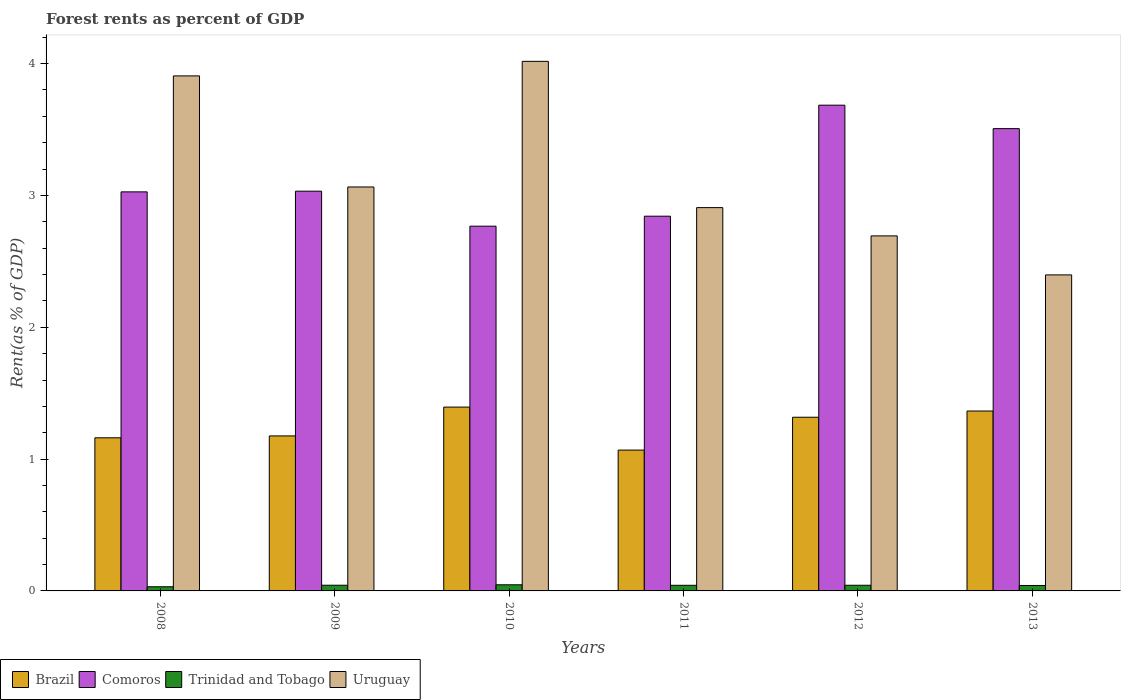How many different coloured bars are there?
Your answer should be very brief. 4. In how many cases, is the number of bars for a given year not equal to the number of legend labels?
Your answer should be very brief. 0. What is the forest rent in Trinidad and Tobago in 2012?
Your response must be concise. 0.04. Across all years, what is the maximum forest rent in Uruguay?
Provide a short and direct response. 4.02. Across all years, what is the minimum forest rent in Uruguay?
Your answer should be very brief. 2.4. In which year was the forest rent in Comoros maximum?
Your answer should be very brief. 2012. What is the total forest rent in Comoros in the graph?
Your response must be concise. 18.86. What is the difference between the forest rent in Brazil in 2011 and that in 2012?
Your response must be concise. -0.25. What is the difference between the forest rent in Comoros in 2011 and the forest rent in Uruguay in 2013?
Your answer should be compact. 0.45. What is the average forest rent in Brazil per year?
Keep it short and to the point. 1.25. In the year 2011, what is the difference between the forest rent in Brazil and forest rent in Comoros?
Your response must be concise. -1.77. In how many years, is the forest rent in Trinidad and Tobago greater than 1 %?
Give a very brief answer. 0. What is the ratio of the forest rent in Trinidad and Tobago in 2008 to that in 2013?
Provide a succinct answer. 0.76. Is the forest rent in Comoros in 2008 less than that in 2010?
Keep it short and to the point. No. Is the difference between the forest rent in Brazil in 2008 and 2010 greater than the difference between the forest rent in Comoros in 2008 and 2010?
Offer a terse response. No. What is the difference between the highest and the second highest forest rent in Trinidad and Tobago?
Offer a very short reply. 0. What is the difference between the highest and the lowest forest rent in Comoros?
Offer a terse response. 0.92. In how many years, is the forest rent in Brazil greater than the average forest rent in Brazil taken over all years?
Your answer should be compact. 3. What does the 4th bar from the right in 2008 represents?
Provide a short and direct response. Brazil. How many bars are there?
Provide a short and direct response. 24. Are all the bars in the graph horizontal?
Provide a short and direct response. No. How many years are there in the graph?
Give a very brief answer. 6. What is the difference between two consecutive major ticks on the Y-axis?
Your response must be concise. 1. Are the values on the major ticks of Y-axis written in scientific E-notation?
Provide a short and direct response. No. Does the graph contain grids?
Ensure brevity in your answer.  No. Where does the legend appear in the graph?
Your answer should be compact. Bottom left. What is the title of the graph?
Offer a very short reply. Forest rents as percent of GDP. What is the label or title of the Y-axis?
Give a very brief answer. Rent(as % of GDP). What is the Rent(as % of GDP) in Brazil in 2008?
Ensure brevity in your answer.  1.16. What is the Rent(as % of GDP) of Comoros in 2008?
Keep it short and to the point. 3.03. What is the Rent(as % of GDP) of Trinidad and Tobago in 2008?
Your response must be concise. 0.03. What is the Rent(as % of GDP) of Uruguay in 2008?
Make the answer very short. 3.91. What is the Rent(as % of GDP) of Brazil in 2009?
Offer a very short reply. 1.18. What is the Rent(as % of GDP) of Comoros in 2009?
Give a very brief answer. 3.03. What is the Rent(as % of GDP) of Trinidad and Tobago in 2009?
Your answer should be very brief. 0.04. What is the Rent(as % of GDP) of Uruguay in 2009?
Offer a terse response. 3.06. What is the Rent(as % of GDP) of Brazil in 2010?
Give a very brief answer. 1.39. What is the Rent(as % of GDP) of Comoros in 2010?
Offer a terse response. 2.77. What is the Rent(as % of GDP) of Trinidad and Tobago in 2010?
Give a very brief answer. 0.05. What is the Rent(as % of GDP) in Uruguay in 2010?
Provide a short and direct response. 4.02. What is the Rent(as % of GDP) of Brazil in 2011?
Make the answer very short. 1.07. What is the Rent(as % of GDP) in Comoros in 2011?
Your answer should be very brief. 2.84. What is the Rent(as % of GDP) of Trinidad and Tobago in 2011?
Your answer should be very brief. 0.04. What is the Rent(as % of GDP) of Uruguay in 2011?
Provide a short and direct response. 2.91. What is the Rent(as % of GDP) in Brazil in 2012?
Provide a succinct answer. 1.32. What is the Rent(as % of GDP) in Comoros in 2012?
Give a very brief answer. 3.68. What is the Rent(as % of GDP) in Trinidad and Tobago in 2012?
Ensure brevity in your answer.  0.04. What is the Rent(as % of GDP) of Uruguay in 2012?
Ensure brevity in your answer.  2.69. What is the Rent(as % of GDP) of Brazil in 2013?
Provide a succinct answer. 1.36. What is the Rent(as % of GDP) of Comoros in 2013?
Offer a very short reply. 3.51. What is the Rent(as % of GDP) in Trinidad and Tobago in 2013?
Provide a succinct answer. 0.04. What is the Rent(as % of GDP) in Uruguay in 2013?
Offer a very short reply. 2.4. Across all years, what is the maximum Rent(as % of GDP) in Brazil?
Your response must be concise. 1.39. Across all years, what is the maximum Rent(as % of GDP) in Comoros?
Give a very brief answer. 3.68. Across all years, what is the maximum Rent(as % of GDP) of Trinidad and Tobago?
Offer a very short reply. 0.05. Across all years, what is the maximum Rent(as % of GDP) of Uruguay?
Offer a very short reply. 4.02. Across all years, what is the minimum Rent(as % of GDP) in Brazil?
Offer a very short reply. 1.07. Across all years, what is the minimum Rent(as % of GDP) of Comoros?
Offer a terse response. 2.77. Across all years, what is the minimum Rent(as % of GDP) of Trinidad and Tobago?
Keep it short and to the point. 0.03. Across all years, what is the minimum Rent(as % of GDP) in Uruguay?
Provide a succinct answer. 2.4. What is the total Rent(as % of GDP) of Brazil in the graph?
Your answer should be very brief. 7.48. What is the total Rent(as % of GDP) of Comoros in the graph?
Provide a succinct answer. 18.86. What is the total Rent(as % of GDP) in Trinidad and Tobago in the graph?
Provide a succinct answer. 0.25. What is the total Rent(as % of GDP) of Uruguay in the graph?
Offer a very short reply. 18.99. What is the difference between the Rent(as % of GDP) in Brazil in 2008 and that in 2009?
Give a very brief answer. -0.01. What is the difference between the Rent(as % of GDP) of Comoros in 2008 and that in 2009?
Provide a succinct answer. -0.01. What is the difference between the Rent(as % of GDP) of Trinidad and Tobago in 2008 and that in 2009?
Offer a very short reply. -0.01. What is the difference between the Rent(as % of GDP) of Uruguay in 2008 and that in 2009?
Provide a succinct answer. 0.84. What is the difference between the Rent(as % of GDP) in Brazil in 2008 and that in 2010?
Provide a short and direct response. -0.23. What is the difference between the Rent(as % of GDP) of Comoros in 2008 and that in 2010?
Keep it short and to the point. 0.26. What is the difference between the Rent(as % of GDP) in Trinidad and Tobago in 2008 and that in 2010?
Ensure brevity in your answer.  -0.01. What is the difference between the Rent(as % of GDP) in Uruguay in 2008 and that in 2010?
Your response must be concise. -0.11. What is the difference between the Rent(as % of GDP) of Brazil in 2008 and that in 2011?
Your response must be concise. 0.09. What is the difference between the Rent(as % of GDP) of Comoros in 2008 and that in 2011?
Your answer should be very brief. 0.18. What is the difference between the Rent(as % of GDP) of Trinidad and Tobago in 2008 and that in 2011?
Ensure brevity in your answer.  -0.01. What is the difference between the Rent(as % of GDP) in Brazil in 2008 and that in 2012?
Your response must be concise. -0.16. What is the difference between the Rent(as % of GDP) of Comoros in 2008 and that in 2012?
Ensure brevity in your answer.  -0.66. What is the difference between the Rent(as % of GDP) in Trinidad and Tobago in 2008 and that in 2012?
Make the answer very short. -0.01. What is the difference between the Rent(as % of GDP) in Uruguay in 2008 and that in 2012?
Offer a terse response. 1.21. What is the difference between the Rent(as % of GDP) in Brazil in 2008 and that in 2013?
Your answer should be very brief. -0.2. What is the difference between the Rent(as % of GDP) in Comoros in 2008 and that in 2013?
Your answer should be very brief. -0.48. What is the difference between the Rent(as % of GDP) of Trinidad and Tobago in 2008 and that in 2013?
Offer a terse response. -0.01. What is the difference between the Rent(as % of GDP) of Uruguay in 2008 and that in 2013?
Your answer should be very brief. 1.51. What is the difference between the Rent(as % of GDP) in Brazil in 2009 and that in 2010?
Your answer should be compact. -0.22. What is the difference between the Rent(as % of GDP) in Comoros in 2009 and that in 2010?
Offer a terse response. 0.27. What is the difference between the Rent(as % of GDP) of Trinidad and Tobago in 2009 and that in 2010?
Provide a succinct answer. -0. What is the difference between the Rent(as % of GDP) in Uruguay in 2009 and that in 2010?
Your response must be concise. -0.95. What is the difference between the Rent(as % of GDP) of Brazil in 2009 and that in 2011?
Offer a very short reply. 0.11. What is the difference between the Rent(as % of GDP) of Comoros in 2009 and that in 2011?
Ensure brevity in your answer.  0.19. What is the difference between the Rent(as % of GDP) of Trinidad and Tobago in 2009 and that in 2011?
Ensure brevity in your answer.  0. What is the difference between the Rent(as % of GDP) of Uruguay in 2009 and that in 2011?
Make the answer very short. 0.16. What is the difference between the Rent(as % of GDP) of Brazil in 2009 and that in 2012?
Your answer should be compact. -0.14. What is the difference between the Rent(as % of GDP) of Comoros in 2009 and that in 2012?
Give a very brief answer. -0.65. What is the difference between the Rent(as % of GDP) of Trinidad and Tobago in 2009 and that in 2012?
Your answer should be very brief. 0. What is the difference between the Rent(as % of GDP) in Uruguay in 2009 and that in 2012?
Offer a very short reply. 0.37. What is the difference between the Rent(as % of GDP) in Brazil in 2009 and that in 2013?
Your response must be concise. -0.19. What is the difference between the Rent(as % of GDP) of Comoros in 2009 and that in 2013?
Offer a very short reply. -0.47. What is the difference between the Rent(as % of GDP) of Trinidad and Tobago in 2009 and that in 2013?
Provide a succinct answer. 0. What is the difference between the Rent(as % of GDP) in Uruguay in 2009 and that in 2013?
Give a very brief answer. 0.67. What is the difference between the Rent(as % of GDP) in Brazil in 2010 and that in 2011?
Your answer should be compact. 0.33. What is the difference between the Rent(as % of GDP) of Comoros in 2010 and that in 2011?
Your answer should be compact. -0.08. What is the difference between the Rent(as % of GDP) in Trinidad and Tobago in 2010 and that in 2011?
Your answer should be compact. 0. What is the difference between the Rent(as % of GDP) in Uruguay in 2010 and that in 2011?
Make the answer very short. 1.11. What is the difference between the Rent(as % of GDP) in Brazil in 2010 and that in 2012?
Offer a very short reply. 0.08. What is the difference between the Rent(as % of GDP) in Comoros in 2010 and that in 2012?
Provide a succinct answer. -0.92. What is the difference between the Rent(as % of GDP) in Trinidad and Tobago in 2010 and that in 2012?
Your response must be concise. 0. What is the difference between the Rent(as % of GDP) in Uruguay in 2010 and that in 2012?
Your answer should be compact. 1.32. What is the difference between the Rent(as % of GDP) in Brazil in 2010 and that in 2013?
Provide a short and direct response. 0.03. What is the difference between the Rent(as % of GDP) of Comoros in 2010 and that in 2013?
Make the answer very short. -0.74. What is the difference between the Rent(as % of GDP) in Trinidad and Tobago in 2010 and that in 2013?
Provide a short and direct response. 0.01. What is the difference between the Rent(as % of GDP) of Uruguay in 2010 and that in 2013?
Ensure brevity in your answer.  1.62. What is the difference between the Rent(as % of GDP) in Brazil in 2011 and that in 2012?
Offer a terse response. -0.25. What is the difference between the Rent(as % of GDP) of Comoros in 2011 and that in 2012?
Give a very brief answer. -0.84. What is the difference between the Rent(as % of GDP) in Trinidad and Tobago in 2011 and that in 2012?
Your answer should be compact. -0. What is the difference between the Rent(as % of GDP) of Uruguay in 2011 and that in 2012?
Give a very brief answer. 0.21. What is the difference between the Rent(as % of GDP) of Brazil in 2011 and that in 2013?
Your answer should be compact. -0.3. What is the difference between the Rent(as % of GDP) in Comoros in 2011 and that in 2013?
Keep it short and to the point. -0.66. What is the difference between the Rent(as % of GDP) in Trinidad and Tobago in 2011 and that in 2013?
Make the answer very short. 0. What is the difference between the Rent(as % of GDP) in Uruguay in 2011 and that in 2013?
Provide a succinct answer. 0.51. What is the difference between the Rent(as % of GDP) of Brazil in 2012 and that in 2013?
Provide a succinct answer. -0.05. What is the difference between the Rent(as % of GDP) of Comoros in 2012 and that in 2013?
Your answer should be compact. 0.18. What is the difference between the Rent(as % of GDP) in Trinidad and Tobago in 2012 and that in 2013?
Provide a short and direct response. 0. What is the difference between the Rent(as % of GDP) of Uruguay in 2012 and that in 2013?
Keep it short and to the point. 0.3. What is the difference between the Rent(as % of GDP) of Brazil in 2008 and the Rent(as % of GDP) of Comoros in 2009?
Provide a short and direct response. -1.87. What is the difference between the Rent(as % of GDP) of Brazil in 2008 and the Rent(as % of GDP) of Trinidad and Tobago in 2009?
Give a very brief answer. 1.12. What is the difference between the Rent(as % of GDP) in Brazil in 2008 and the Rent(as % of GDP) in Uruguay in 2009?
Your answer should be very brief. -1.9. What is the difference between the Rent(as % of GDP) of Comoros in 2008 and the Rent(as % of GDP) of Trinidad and Tobago in 2009?
Your response must be concise. 2.98. What is the difference between the Rent(as % of GDP) in Comoros in 2008 and the Rent(as % of GDP) in Uruguay in 2009?
Offer a terse response. -0.04. What is the difference between the Rent(as % of GDP) of Trinidad and Tobago in 2008 and the Rent(as % of GDP) of Uruguay in 2009?
Provide a short and direct response. -3.03. What is the difference between the Rent(as % of GDP) in Brazil in 2008 and the Rent(as % of GDP) in Comoros in 2010?
Keep it short and to the point. -1.61. What is the difference between the Rent(as % of GDP) in Brazil in 2008 and the Rent(as % of GDP) in Trinidad and Tobago in 2010?
Your answer should be very brief. 1.12. What is the difference between the Rent(as % of GDP) in Brazil in 2008 and the Rent(as % of GDP) in Uruguay in 2010?
Make the answer very short. -2.86. What is the difference between the Rent(as % of GDP) in Comoros in 2008 and the Rent(as % of GDP) in Trinidad and Tobago in 2010?
Make the answer very short. 2.98. What is the difference between the Rent(as % of GDP) in Comoros in 2008 and the Rent(as % of GDP) in Uruguay in 2010?
Make the answer very short. -0.99. What is the difference between the Rent(as % of GDP) of Trinidad and Tobago in 2008 and the Rent(as % of GDP) of Uruguay in 2010?
Offer a very short reply. -3.99. What is the difference between the Rent(as % of GDP) of Brazil in 2008 and the Rent(as % of GDP) of Comoros in 2011?
Make the answer very short. -1.68. What is the difference between the Rent(as % of GDP) of Brazil in 2008 and the Rent(as % of GDP) of Trinidad and Tobago in 2011?
Keep it short and to the point. 1.12. What is the difference between the Rent(as % of GDP) of Brazil in 2008 and the Rent(as % of GDP) of Uruguay in 2011?
Your response must be concise. -1.75. What is the difference between the Rent(as % of GDP) in Comoros in 2008 and the Rent(as % of GDP) in Trinidad and Tobago in 2011?
Give a very brief answer. 2.98. What is the difference between the Rent(as % of GDP) of Comoros in 2008 and the Rent(as % of GDP) of Uruguay in 2011?
Your response must be concise. 0.12. What is the difference between the Rent(as % of GDP) in Trinidad and Tobago in 2008 and the Rent(as % of GDP) in Uruguay in 2011?
Give a very brief answer. -2.88. What is the difference between the Rent(as % of GDP) of Brazil in 2008 and the Rent(as % of GDP) of Comoros in 2012?
Provide a succinct answer. -2.52. What is the difference between the Rent(as % of GDP) in Brazil in 2008 and the Rent(as % of GDP) in Trinidad and Tobago in 2012?
Make the answer very short. 1.12. What is the difference between the Rent(as % of GDP) in Brazil in 2008 and the Rent(as % of GDP) in Uruguay in 2012?
Offer a terse response. -1.53. What is the difference between the Rent(as % of GDP) of Comoros in 2008 and the Rent(as % of GDP) of Trinidad and Tobago in 2012?
Offer a terse response. 2.98. What is the difference between the Rent(as % of GDP) in Comoros in 2008 and the Rent(as % of GDP) in Uruguay in 2012?
Keep it short and to the point. 0.33. What is the difference between the Rent(as % of GDP) of Trinidad and Tobago in 2008 and the Rent(as % of GDP) of Uruguay in 2012?
Your answer should be very brief. -2.66. What is the difference between the Rent(as % of GDP) in Brazil in 2008 and the Rent(as % of GDP) in Comoros in 2013?
Offer a very short reply. -2.35. What is the difference between the Rent(as % of GDP) of Brazil in 2008 and the Rent(as % of GDP) of Trinidad and Tobago in 2013?
Offer a terse response. 1.12. What is the difference between the Rent(as % of GDP) in Brazil in 2008 and the Rent(as % of GDP) in Uruguay in 2013?
Make the answer very short. -1.24. What is the difference between the Rent(as % of GDP) in Comoros in 2008 and the Rent(as % of GDP) in Trinidad and Tobago in 2013?
Provide a succinct answer. 2.99. What is the difference between the Rent(as % of GDP) in Comoros in 2008 and the Rent(as % of GDP) in Uruguay in 2013?
Offer a very short reply. 0.63. What is the difference between the Rent(as % of GDP) of Trinidad and Tobago in 2008 and the Rent(as % of GDP) of Uruguay in 2013?
Your response must be concise. -2.37. What is the difference between the Rent(as % of GDP) in Brazil in 2009 and the Rent(as % of GDP) in Comoros in 2010?
Offer a very short reply. -1.59. What is the difference between the Rent(as % of GDP) in Brazil in 2009 and the Rent(as % of GDP) in Trinidad and Tobago in 2010?
Your answer should be compact. 1.13. What is the difference between the Rent(as % of GDP) in Brazil in 2009 and the Rent(as % of GDP) in Uruguay in 2010?
Offer a very short reply. -2.84. What is the difference between the Rent(as % of GDP) in Comoros in 2009 and the Rent(as % of GDP) in Trinidad and Tobago in 2010?
Ensure brevity in your answer.  2.99. What is the difference between the Rent(as % of GDP) in Comoros in 2009 and the Rent(as % of GDP) in Uruguay in 2010?
Make the answer very short. -0.98. What is the difference between the Rent(as % of GDP) in Trinidad and Tobago in 2009 and the Rent(as % of GDP) in Uruguay in 2010?
Your answer should be very brief. -3.97. What is the difference between the Rent(as % of GDP) in Brazil in 2009 and the Rent(as % of GDP) in Comoros in 2011?
Make the answer very short. -1.67. What is the difference between the Rent(as % of GDP) in Brazil in 2009 and the Rent(as % of GDP) in Trinidad and Tobago in 2011?
Your answer should be compact. 1.13. What is the difference between the Rent(as % of GDP) in Brazil in 2009 and the Rent(as % of GDP) in Uruguay in 2011?
Give a very brief answer. -1.73. What is the difference between the Rent(as % of GDP) of Comoros in 2009 and the Rent(as % of GDP) of Trinidad and Tobago in 2011?
Offer a very short reply. 2.99. What is the difference between the Rent(as % of GDP) in Comoros in 2009 and the Rent(as % of GDP) in Uruguay in 2011?
Your answer should be compact. 0.12. What is the difference between the Rent(as % of GDP) in Trinidad and Tobago in 2009 and the Rent(as % of GDP) in Uruguay in 2011?
Offer a very short reply. -2.86. What is the difference between the Rent(as % of GDP) in Brazil in 2009 and the Rent(as % of GDP) in Comoros in 2012?
Your answer should be compact. -2.51. What is the difference between the Rent(as % of GDP) of Brazil in 2009 and the Rent(as % of GDP) of Trinidad and Tobago in 2012?
Offer a very short reply. 1.13. What is the difference between the Rent(as % of GDP) of Brazil in 2009 and the Rent(as % of GDP) of Uruguay in 2012?
Give a very brief answer. -1.52. What is the difference between the Rent(as % of GDP) in Comoros in 2009 and the Rent(as % of GDP) in Trinidad and Tobago in 2012?
Your answer should be very brief. 2.99. What is the difference between the Rent(as % of GDP) in Comoros in 2009 and the Rent(as % of GDP) in Uruguay in 2012?
Your answer should be compact. 0.34. What is the difference between the Rent(as % of GDP) in Trinidad and Tobago in 2009 and the Rent(as % of GDP) in Uruguay in 2012?
Provide a short and direct response. -2.65. What is the difference between the Rent(as % of GDP) in Brazil in 2009 and the Rent(as % of GDP) in Comoros in 2013?
Ensure brevity in your answer.  -2.33. What is the difference between the Rent(as % of GDP) in Brazil in 2009 and the Rent(as % of GDP) in Trinidad and Tobago in 2013?
Keep it short and to the point. 1.13. What is the difference between the Rent(as % of GDP) in Brazil in 2009 and the Rent(as % of GDP) in Uruguay in 2013?
Your answer should be compact. -1.22. What is the difference between the Rent(as % of GDP) in Comoros in 2009 and the Rent(as % of GDP) in Trinidad and Tobago in 2013?
Your answer should be very brief. 2.99. What is the difference between the Rent(as % of GDP) in Comoros in 2009 and the Rent(as % of GDP) in Uruguay in 2013?
Keep it short and to the point. 0.64. What is the difference between the Rent(as % of GDP) of Trinidad and Tobago in 2009 and the Rent(as % of GDP) of Uruguay in 2013?
Offer a terse response. -2.35. What is the difference between the Rent(as % of GDP) of Brazil in 2010 and the Rent(as % of GDP) of Comoros in 2011?
Keep it short and to the point. -1.45. What is the difference between the Rent(as % of GDP) of Brazil in 2010 and the Rent(as % of GDP) of Trinidad and Tobago in 2011?
Offer a very short reply. 1.35. What is the difference between the Rent(as % of GDP) in Brazil in 2010 and the Rent(as % of GDP) in Uruguay in 2011?
Your answer should be compact. -1.51. What is the difference between the Rent(as % of GDP) of Comoros in 2010 and the Rent(as % of GDP) of Trinidad and Tobago in 2011?
Offer a very short reply. 2.72. What is the difference between the Rent(as % of GDP) in Comoros in 2010 and the Rent(as % of GDP) in Uruguay in 2011?
Your response must be concise. -0.14. What is the difference between the Rent(as % of GDP) in Trinidad and Tobago in 2010 and the Rent(as % of GDP) in Uruguay in 2011?
Offer a terse response. -2.86. What is the difference between the Rent(as % of GDP) of Brazil in 2010 and the Rent(as % of GDP) of Comoros in 2012?
Offer a terse response. -2.29. What is the difference between the Rent(as % of GDP) of Brazil in 2010 and the Rent(as % of GDP) of Trinidad and Tobago in 2012?
Your response must be concise. 1.35. What is the difference between the Rent(as % of GDP) of Brazil in 2010 and the Rent(as % of GDP) of Uruguay in 2012?
Provide a succinct answer. -1.3. What is the difference between the Rent(as % of GDP) in Comoros in 2010 and the Rent(as % of GDP) in Trinidad and Tobago in 2012?
Your response must be concise. 2.72. What is the difference between the Rent(as % of GDP) of Comoros in 2010 and the Rent(as % of GDP) of Uruguay in 2012?
Provide a succinct answer. 0.07. What is the difference between the Rent(as % of GDP) in Trinidad and Tobago in 2010 and the Rent(as % of GDP) in Uruguay in 2012?
Give a very brief answer. -2.65. What is the difference between the Rent(as % of GDP) of Brazil in 2010 and the Rent(as % of GDP) of Comoros in 2013?
Offer a terse response. -2.11. What is the difference between the Rent(as % of GDP) in Brazil in 2010 and the Rent(as % of GDP) in Trinidad and Tobago in 2013?
Make the answer very short. 1.35. What is the difference between the Rent(as % of GDP) of Brazil in 2010 and the Rent(as % of GDP) of Uruguay in 2013?
Provide a short and direct response. -1. What is the difference between the Rent(as % of GDP) of Comoros in 2010 and the Rent(as % of GDP) of Trinidad and Tobago in 2013?
Your answer should be very brief. 2.73. What is the difference between the Rent(as % of GDP) of Comoros in 2010 and the Rent(as % of GDP) of Uruguay in 2013?
Provide a succinct answer. 0.37. What is the difference between the Rent(as % of GDP) in Trinidad and Tobago in 2010 and the Rent(as % of GDP) in Uruguay in 2013?
Ensure brevity in your answer.  -2.35. What is the difference between the Rent(as % of GDP) in Brazil in 2011 and the Rent(as % of GDP) in Comoros in 2012?
Give a very brief answer. -2.62. What is the difference between the Rent(as % of GDP) of Brazil in 2011 and the Rent(as % of GDP) of Trinidad and Tobago in 2012?
Ensure brevity in your answer.  1.03. What is the difference between the Rent(as % of GDP) in Brazil in 2011 and the Rent(as % of GDP) in Uruguay in 2012?
Offer a terse response. -1.62. What is the difference between the Rent(as % of GDP) in Comoros in 2011 and the Rent(as % of GDP) in Trinidad and Tobago in 2012?
Keep it short and to the point. 2.8. What is the difference between the Rent(as % of GDP) of Comoros in 2011 and the Rent(as % of GDP) of Uruguay in 2012?
Ensure brevity in your answer.  0.15. What is the difference between the Rent(as % of GDP) of Trinidad and Tobago in 2011 and the Rent(as % of GDP) of Uruguay in 2012?
Give a very brief answer. -2.65. What is the difference between the Rent(as % of GDP) in Brazil in 2011 and the Rent(as % of GDP) in Comoros in 2013?
Provide a short and direct response. -2.44. What is the difference between the Rent(as % of GDP) of Brazil in 2011 and the Rent(as % of GDP) of Trinidad and Tobago in 2013?
Make the answer very short. 1.03. What is the difference between the Rent(as % of GDP) of Brazil in 2011 and the Rent(as % of GDP) of Uruguay in 2013?
Make the answer very short. -1.33. What is the difference between the Rent(as % of GDP) of Comoros in 2011 and the Rent(as % of GDP) of Trinidad and Tobago in 2013?
Offer a terse response. 2.8. What is the difference between the Rent(as % of GDP) of Comoros in 2011 and the Rent(as % of GDP) of Uruguay in 2013?
Ensure brevity in your answer.  0.45. What is the difference between the Rent(as % of GDP) in Trinidad and Tobago in 2011 and the Rent(as % of GDP) in Uruguay in 2013?
Give a very brief answer. -2.35. What is the difference between the Rent(as % of GDP) in Brazil in 2012 and the Rent(as % of GDP) in Comoros in 2013?
Offer a very short reply. -2.19. What is the difference between the Rent(as % of GDP) in Brazil in 2012 and the Rent(as % of GDP) in Trinidad and Tobago in 2013?
Your answer should be compact. 1.28. What is the difference between the Rent(as % of GDP) in Brazil in 2012 and the Rent(as % of GDP) in Uruguay in 2013?
Ensure brevity in your answer.  -1.08. What is the difference between the Rent(as % of GDP) in Comoros in 2012 and the Rent(as % of GDP) in Trinidad and Tobago in 2013?
Your answer should be very brief. 3.64. What is the difference between the Rent(as % of GDP) of Comoros in 2012 and the Rent(as % of GDP) of Uruguay in 2013?
Ensure brevity in your answer.  1.29. What is the difference between the Rent(as % of GDP) in Trinidad and Tobago in 2012 and the Rent(as % of GDP) in Uruguay in 2013?
Your answer should be compact. -2.35. What is the average Rent(as % of GDP) in Brazil per year?
Make the answer very short. 1.25. What is the average Rent(as % of GDP) in Comoros per year?
Provide a succinct answer. 3.14. What is the average Rent(as % of GDP) in Trinidad and Tobago per year?
Offer a terse response. 0.04. What is the average Rent(as % of GDP) of Uruguay per year?
Your response must be concise. 3.16. In the year 2008, what is the difference between the Rent(as % of GDP) in Brazil and Rent(as % of GDP) in Comoros?
Provide a short and direct response. -1.87. In the year 2008, what is the difference between the Rent(as % of GDP) in Brazil and Rent(as % of GDP) in Trinidad and Tobago?
Give a very brief answer. 1.13. In the year 2008, what is the difference between the Rent(as % of GDP) in Brazil and Rent(as % of GDP) in Uruguay?
Make the answer very short. -2.75. In the year 2008, what is the difference between the Rent(as % of GDP) in Comoros and Rent(as % of GDP) in Trinidad and Tobago?
Your response must be concise. 3. In the year 2008, what is the difference between the Rent(as % of GDP) of Comoros and Rent(as % of GDP) of Uruguay?
Your answer should be very brief. -0.88. In the year 2008, what is the difference between the Rent(as % of GDP) of Trinidad and Tobago and Rent(as % of GDP) of Uruguay?
Ensure brevity in your answer.  -3.88. In the year 2009, what is the difference between the Rent(as % of GDP) in Brazil and Rent(as % of GDP) in Comoros?
Your response must be concise. -1.86. In the year 2009, what is the difference between the Rent(as % of GDP) of Brazil and Rent(as % of GDP) of Trinidad and Tobago?
Offer a very short reply. 1.13. In the year 2009, what is the difference between the Rent(as % of GDP) of Brazil and Rent(as % of GDP) of Uruguay?
Your answer should be compact. -1.89. In the year 2009, what is the difference between the Rent(as % of GDP) of Comoros and Rent(as % of GDP) of Trinidad and Tobago?
Your response must be concise. 2.99. In the year 2009, what is the difference between the Rent(as % of GDP) in Comoros and Rent(as % of GDP) in Uruguay?
Offer a very short reply. -0.03. In the year 2009, what is the difference between the Rent(as % of GDP) in Trinidad and Tobago and Rent(as % of GDP) in Uruguay?
Your answer should be compact. -3.02. In the year 2010, what is the difference between the Rent(as % of GDP) in Brazil and Rent(as % of GDP) in Comoros?
Offer a very short reply. -1.37. In the year 2010, what is the difference between the Rent(as % of GDP) in Brazil and Rent(as % of GDP) in Trinidad and Tobago?
Your response must be concise. 1.35. In the year 2010, what is the difference between the Rent(as % of GDP) in Brazil and Rent(as % of GDP) in Uruguay?
Provide a short and direct response. -2.62. In the year 2010, what is the difference between the Rent(as % of GDP) of Comoros and Rent(as % of GDP) of Trinidad and Tobago?
Your answer should be very brief. 2.72. In the year 2010, what is the difference between the Rent(as % of GDP) in Comoros and Rent(as % of GDP) in Uruguay?
Provide a short and direct response. -1.25. In the year 2010, what is the difference between the Rent(as % of GDP) of Trinidad and Tobago and Rent(as % of GDP) of Uruguay?
Your answer should be compact. -3.97. In the year 2011, what is the difference between the Rent(as % of GDP) in Brazil and Rent(as % of GDP) in Comoros?
Provide a short and direct response. -1.77. In the year 2011, what is the difference between the Rent(as % of GDP) of Brazil and Rent(as % of GDP) of Trinidad and Tobago?
Provide a short and direct response. 1.03. In the year 2011, what is the difference between the Rent(as % of GDP) of Brazil and Rent(as % of GDP) of Uruguay?
Ensure brevity in your answer.  -1.84. In the year 2011, what is the difference between the Rent(as % of GDP) of Comoros and Rent(as % of GDP) of Uruguay?
Make the answer very short. -0.07. In the year 2011, what is the difference between the Rent(as % of GDP) of Trinidad and Tobago and Rent(as % of GDP) of Uruguay?
Your answer should be very brief. -2.87. In the year 2012, what is the difference between the Rent(as % of GDP) in Brazil and Rent(as % of GDP) in Comoros?
Keep it short and to the point. -2.37. In the year 2012, what is the difference between the Rent(as % of GDP) of Brazil and Rent(as % of GDP) of Trinidad and Tobago?
Your answer should be compact. 1.27. In the year 2012, what is the difference between the Rent(as % of GDP) of Brazil and Rent(as % of GDP) of Uruguay?
Make the answer very short. -1.38. In the year 2012, what is the difference between the Rent(as % of GDP) of Comoros and Rent(as % of GDP) of Trinidad and Tobago?
Provide a short and direct response. 3.64. In the year 2012, what is the difference between the Rent(as % of GDP) of Comoros and Rent(as % of GDP) of Uruguay?
Give a very brief answer. 0.99. In the year 2012, what is the difference between the Rent(as % of GDP) in Trinidad and Tobago and Rent(as % of GDP) in Uruguay?
Provide a succinct answer. -2.65. In the year 2013, what is the difference between the Rent(as % of GDP) in Brazil and Rent(as % of GDP) in Comoros?
Provide a succinct answer. -2.14. In the year 2013, what is the difference between the Rent(as % of GDP) of Brazil and Rent(as % of GDP) of Trinidad and Tobago?
Your answer should be very brief. 1.32. In the year 2013, what is the difference between the Rent(as % of GDP) in Brazil and Rent(as % of GDP) in Uruguay?
Your response must be concise. -1.03. In the year 2013, what is the difference between the Rent(as % of GDP) of Comoros and Rent(as % of GDP) of Trinidad and Tobago?
Give a very brief answer. 3.47. In the year 2013, what is the difference between the Rent(as % of GDP) in Comoros and Rent(as % of GDP) in Uruguay?
Provide a succinct answer. 1.11. In the year 2013, what is the difference between the Rent(as % of GDP) of Trinidad and Tobago and Rent(as % of GDP) of Uruguay?
Offer a terse response. -2.36. What is the ratio of the Rent(as % of GDP) in Brazil in 2008 to that in 2009?
Make the answer very short. 0.99. What is the ratio of the Rent(as % of GDP) in Comoros in 2008 to that in 2009?
Your answer should be compact. 1. What is the ratio of the Rent(as % of GDP) of Trinidad and Tobago in 2008 to that in 2009?
Ensure brevity in your answer.  0.73. What is the ratio of the Rent(as % of GDP) in Uruguay in 2008 to that in 2009?
Your response must be concise. 1.27. What is the ratio of the Rent(as % of GDP) in Brazil in 2008 to that in 2010?
Offer a terse response. 0.83. What is the ratio of the Rent(as % of GDP) of Comoros in 2008 to that in 2010?
Make the answer very short. 1.09. What is the ratio of the Rent(as % of GDP) in Trinidad and Tobago in 2008 to that in 2010?
Your response must be concise. 0.68. What is the ratio of the Rent(as % of GDP) in Uruguay in 2008 to that in 2010?
Your answer should be compact. 0.97. What is the ratio of the Rent(as % of GDP) in Brazil in 2008 to that in 2011?
Your answer should be very brief. 1.09. What is the ratio of the Rent(as % of GDP) of Comoros in 2008 to that in 2011?
Ensure brevity in your answer.  1.06. What is the ratio of the Rent(as % of GDP) in Trinidad and Tobago in 2008 to that in 2011?
Give a very brief answer. 0.74. What is the ratio of the Rent(as % of GDP) of Uruguay in 2008 to that in 2011?
Offer a very short reply. 1.34. What is the ratio of the Rent(as % of GDP) of Brazil in 2008 to that in 2012?
Make the answer very short. 0.88. What is the ratio of the Rent(as % of GDP) of Comoros in 2008 to that in 2012?
Your answer should be very brief. 0.82. What is the ratio of the Rent(as % of GDP) in Trinidad and Tobago in 2008 to that in 2012?
Provide a succinct answer. 0.74. What is the ratio of the Rent(as % of GDP) of Uruguay in 2008 to that in 2012?
Keep it short and to the point. 1.45. What is the ratio of the Rent(as % of GDP) of Brazil in 2008 to that in 2013?
Ensure brevity in your answer.  0.85. What is the ratio of the Rent(as % of GDP) in Comoros in 2008 to that in 2013?
Make the answer very short. 0.86. What is the ratio of the Rent(as % of GDP) of Trinidad and Tobago in 2008 to that in 2013?
Provide a short and direct response. 0.76. What is the ratio of the Rent(as % of GDP) in Uruguay in 2008 to that in 2013?
Your answer should be very brief. 1.63. What is the ratio of the Rent(as % of GDP) in Brazil in 2009 to that in 2010?
Offer a terse response. 0.84. What is the ratio of the Rent(as % of GDP) in Comoros in 2009 to that in 2010?
Make the answer very short. 1.1. What is the ratio of the Rent(as % of GDP) of Trinidad and Tobago in 2009 to that in 2010?
Offer a very short reply. 0.93. What is the ratio of the Rent(as % of GDP) of Uruguay in 2009 to that in 2010?
Keep it short and to the point. 0.76. What is the ratio of the Rent(as % of GDP) of Brazil in 2009 to that in 2011?
Offer a very short reply. 1.1. What is the ratio of the Rent(as % of GDP) of Comoros in 2009 to that in 2011?
Provide a succinct answer. 1.07. What is the ratio of the Rent(as % of GDP) in Trinidad and Tobago in 2009 to that in 2011?
Ensure brevity in your answer.  1.02. What is the ratio of the Rent(as % of GDP) of Uruguay in 2009 to that in 2011?
Your answer should be compact. 1.05. What is the ratio of the Rent(as % of GDP) in Brazil in 2009 to that in 2012?
Provide a succinct answer. 0.89. What is the ratio of the Rent(as % of GDP) in Comoros in 2009 to that in 2012?
Your answer should be very brief. 0.82. What is the ratio of the Rent(as % of GDP) of Trinidad and Tobago in 2009 to that in 2012?
Provide a short and direct response. 1.01. What is the ratio of the Rent(as % of GDP) of Uruguay in 2009 to that in 2012?
Your answer should be very brief. 1.14. What is the ratio of the Rent(as % of GDP) in Brazil in 2009 to that in 2013?
Your answer should be compact. 0.86. What is the ratio of the Rent(as % of GDP) of Comoros in 2009 to that in 2013?
Make the answer very short. 0.86. What is the ratio of the Rent(as % of GDP) in Trinidad and Tobago in 2009 to that in 2013?
Keep it short and to the point. 1.05. What is the ratio of the Rent(as % of GDP) of Uruguay in 2009 to that in 2013?
Provide a short and direct response. 1.28. What is the ratio of the Rent(as % of GDP) of Brazil in 2010 to that in 2011?
Your response must be concise. 1.31. What is the ratio of the Rent(as % of GDP) of Comoros in 2010 to that in 2011?
Give a very brief answer. 0.97. What is the ratio of the Rent(as % of GDP) in Trinidad and Tobago in 2010 to that in 2011?
Keep it short and to the point. 1.09. What is the ratio of the Rent(as % of GDP) in Uruguay in 2010 to that in 2011?
Give a very brief answer. 1.38. What is the ratio of the Rent(as % of GDP) in Brazil in 2010 to that in 2012?
Offer a very short reply. 1.06. What is the ratio of the Rent(as % of GDP) of Comoros in 2010 to that in 2012?
Give a very brief answer. 0.75. What is the ratio of the Rent(as % of GDP) in Trinidad and Tobago in 2010 to that in 2012?
Provide a short and direct response. 1.08. What is the ratio of the Rent(as % of GDP) in Uruguay in 2010 to that in 2012?
Your answer should be compact. 1.49. What is the ratio of the Rent(as % of GDP) of Brazil in 2010 to that in 2013?
Make the answer very short. 1.02. What is the ratio of the Rent(as % of GDP) in Comoros in 2010 to that in 2013?
Your answer should be compact. 0.79. What is the ratio of the Rent(as % of GDP) of Trinidad and Tobago in 2010 to that in 2013?
Keep it short and to the point. 1.13. What is the ratio of the Rent(as % of GDP) of Uruguay in 2010 to that in 2013?
Ensure brevity in your answer.  1.68. What is the ratio of the Rent(as % of GDP) in Brazil in 2011 to that in 2012?
Offer a terse response. 0.81. What is the ratio of the Rent(as % of GDP) of Comoros in 2011 to that in 2012?
Make the answer very short. 0.77. What is the ratio of the Rent(as % of GDP) of Uruguay in 2011 to that in 2012?
Offer a very short reply. 1.08. What is the ratio of the Rent(as % of GDP) of Brazil in 2011 to that in 2013?
Your answer should be very brief. 0.78. What is the ratio of the Rent(as % of GDP) in Comoros in 2011 to that in 2013?
Your response must be concise. 0.81. What is the ratio of the Rent(as % of GDP) of Trinidad and Tobago in 2011 to that in 2013?
Your answer should be compact. 1.03. What is the ratio of the Rent(as % of GDP) in Uruguay in 2011 to that in 2013?
Keep it short and to the point. 1.21. What is the ratio of the Rent(as % of GDP) in Brazil in 2012 to that in 2013?
Your response must be concise. 0.97. What is the ratio of the Rent(as % of GDP) in Comoros in 2012 to that in 2013?
Give a very brief answer. 1.05. What is the ratio of the Rent(as % of GDP) of Trinidad and Tobago in 2012 to that in 2013?
Your answer should be very brief. 1.04. What is the ratio of the Rent(as % of GDP) in Uruguay in 2012 to that in 2013?
Keep it short and to the point. 1.12. What is the difference between the highest and the second highest Rent(as % of GDP) of Brazil?
Offer a terse response. 0.03. What is the difference between the highest and the second highest Rent(as % of GDP) in Comoros?
Make the answer very short. 0.18. What is the difference between the highest and the second highest Rent(as % of GDP) of Trinidad and Tobago?
Ensure brevity in your answer.  0. What is the difference between the highest and the second highest Rent(as % of GDP) in Uruguay?
Give a very brief answer. 0.11. What is the difference between the highest and the lowest Rent(as % of GDP) in Brazil?
Make the answer very short. 0.33. What is the difference between the highest and the lowest Rent(as % of GDP) in Comoros?
Provide a short and direct response. 0.92. What is the difference between the highest and the lowest Rent(as % of GDP) of Trinidad and Tobago?
Your response must be concise. 0.01. What is the difference between the highest and the lowest Rent(as % of GDP) of Uruguay?
Keep it short and to the point. 1.62. 